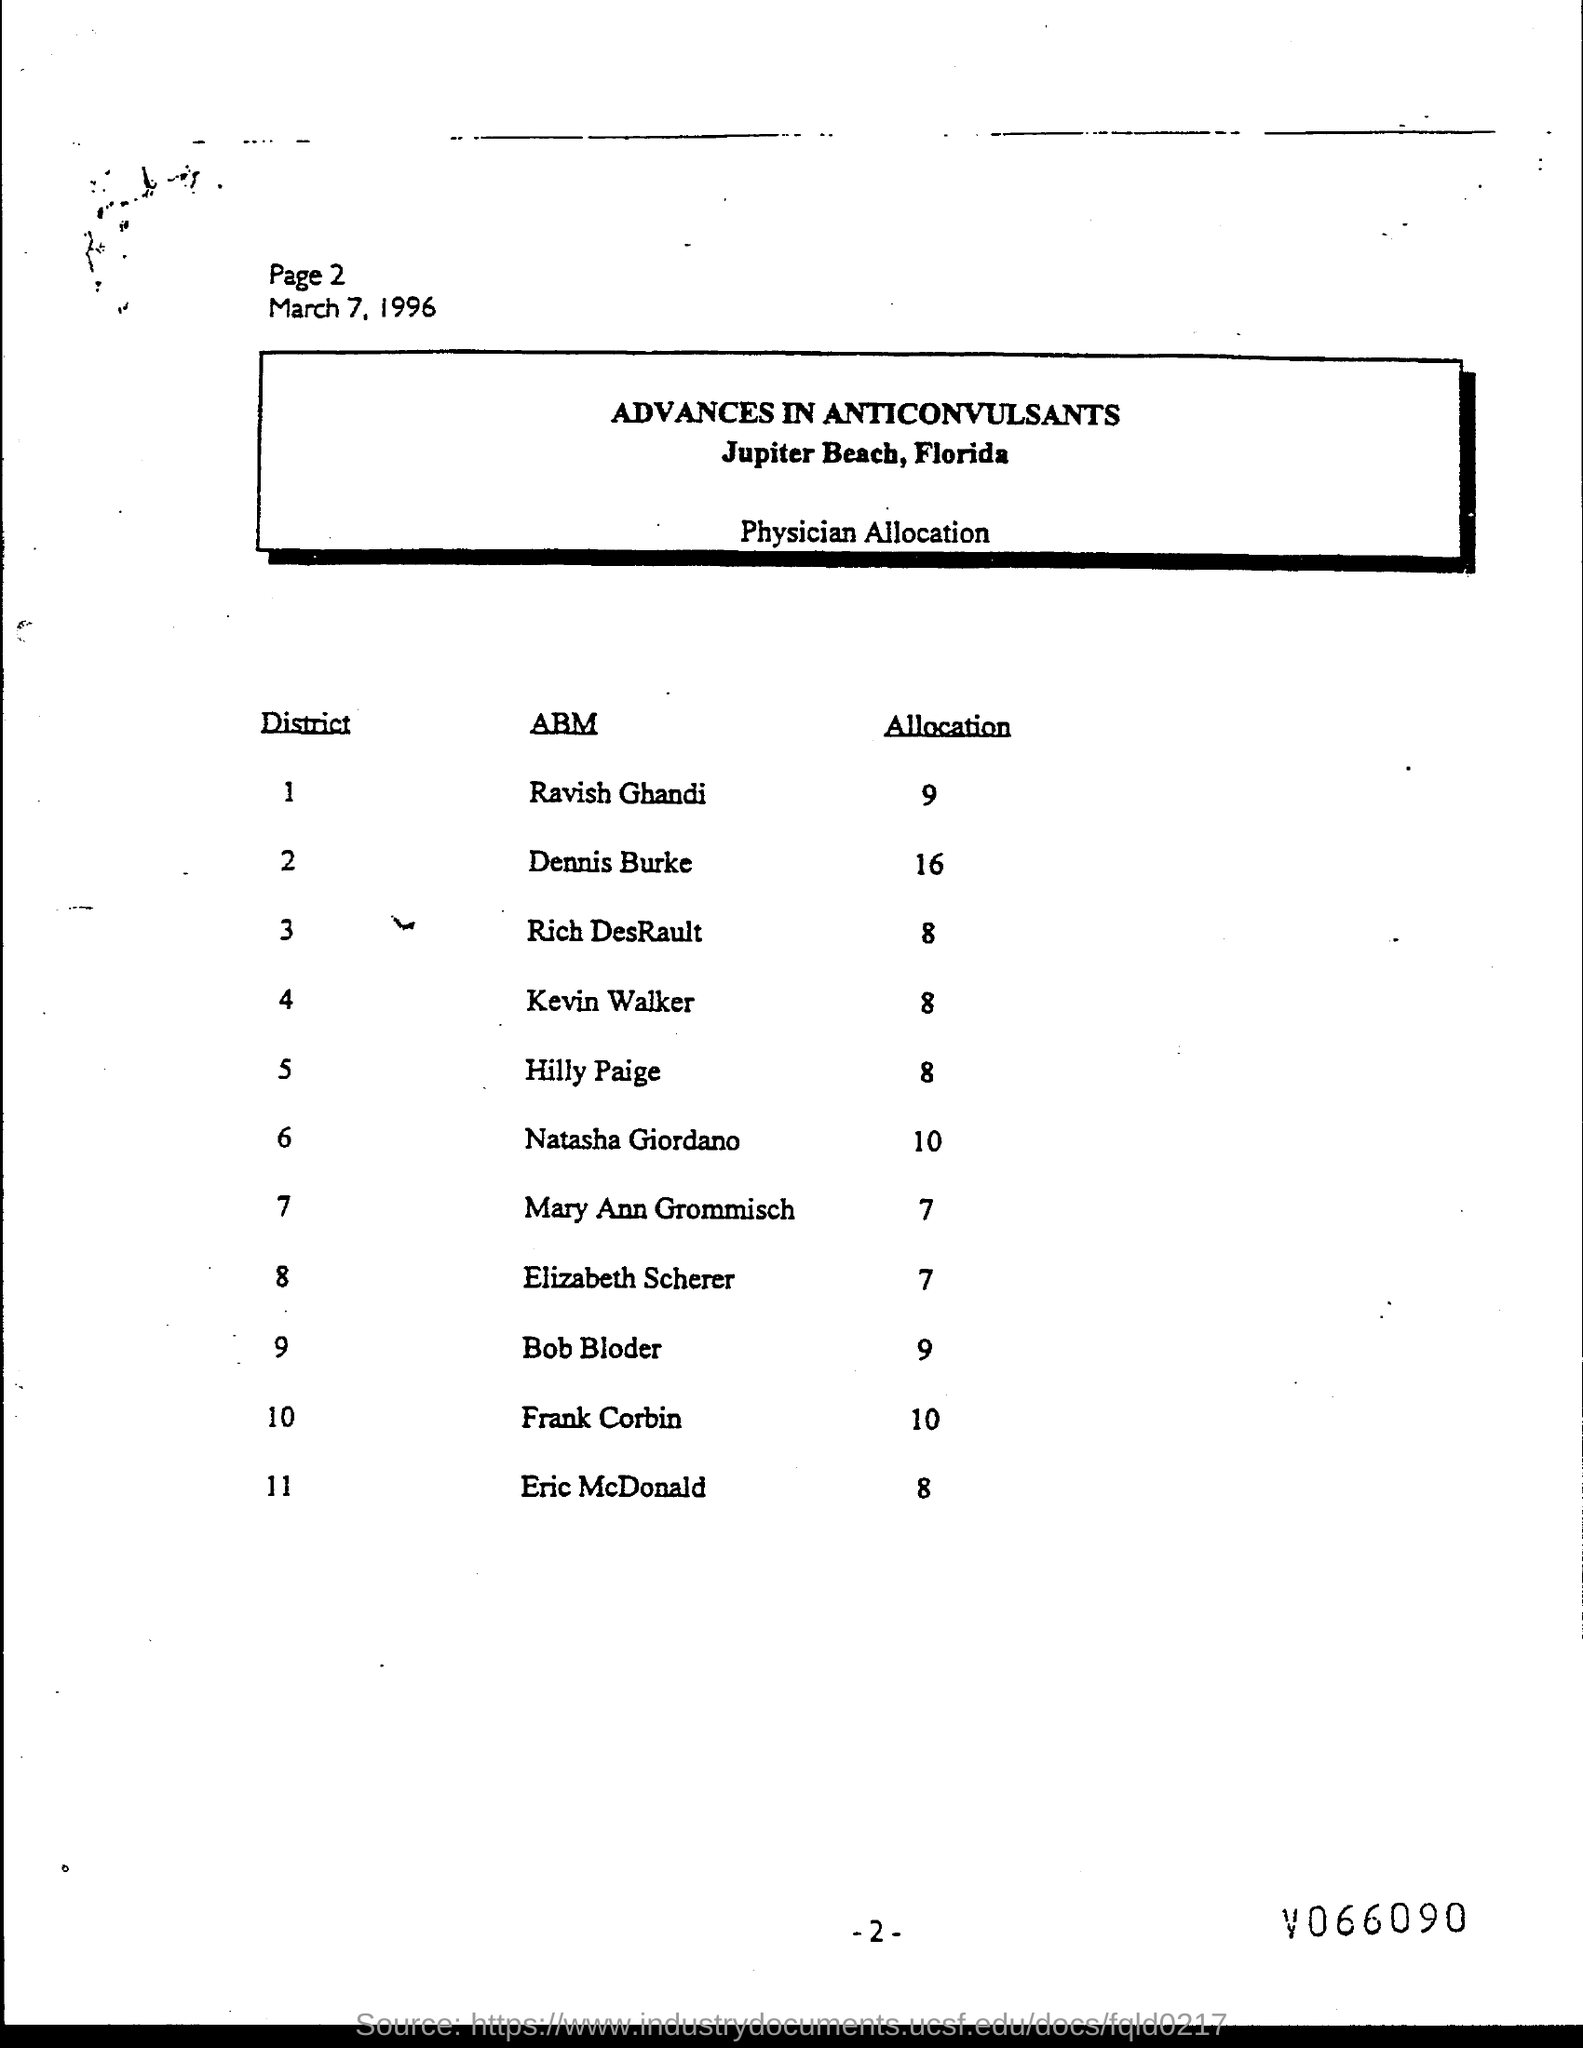What is the page number at top of the page?
Keep it short and to the point. Page 2. What are allocation for ravish ghandi ?
Offer a very short reply. 9. What are allocation for dennis burke ?
Your response must be concise. 16. What are allocation for rich desrault ?
Your answer should be compact. 8. What is date below page number ?
Provide a short and direct response. March 7, 1996. What are allocation for kevin walker ?
Your answer should be compact. 8. What are allocation for hilly paige?
Keep it short and to the point. 8. What are allocation natasha giordano ?
Offer a terse response. 10. What are allocation for bob bloder ?
Give a very brief answer. 9. 